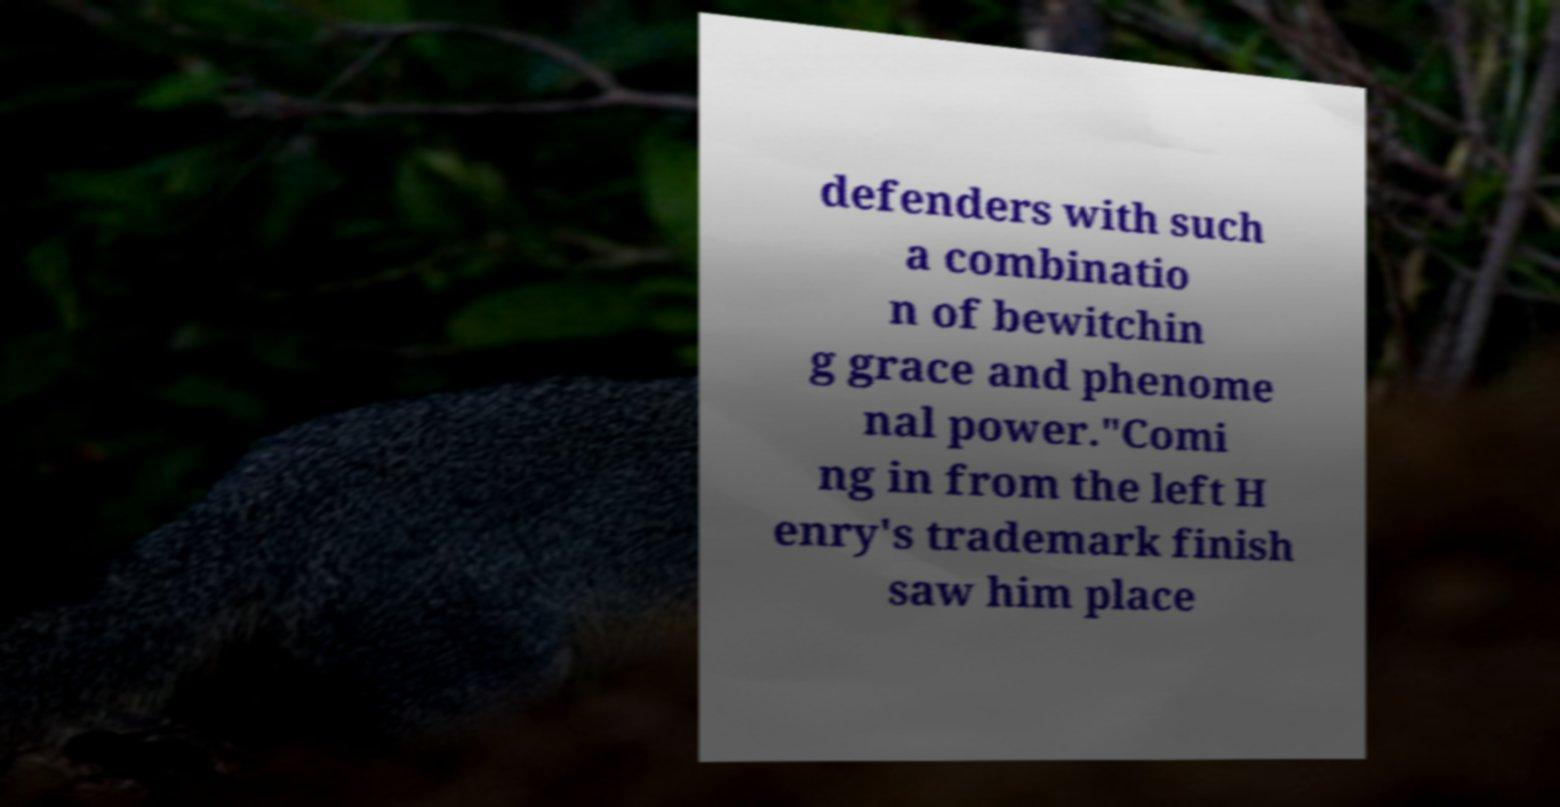Please identify and transcribe the text found in this image. defenders with such a combinatio n of bewitchin g grace and phenome nal power."Comi ng in from the left H enry's trademark finish saw him place 